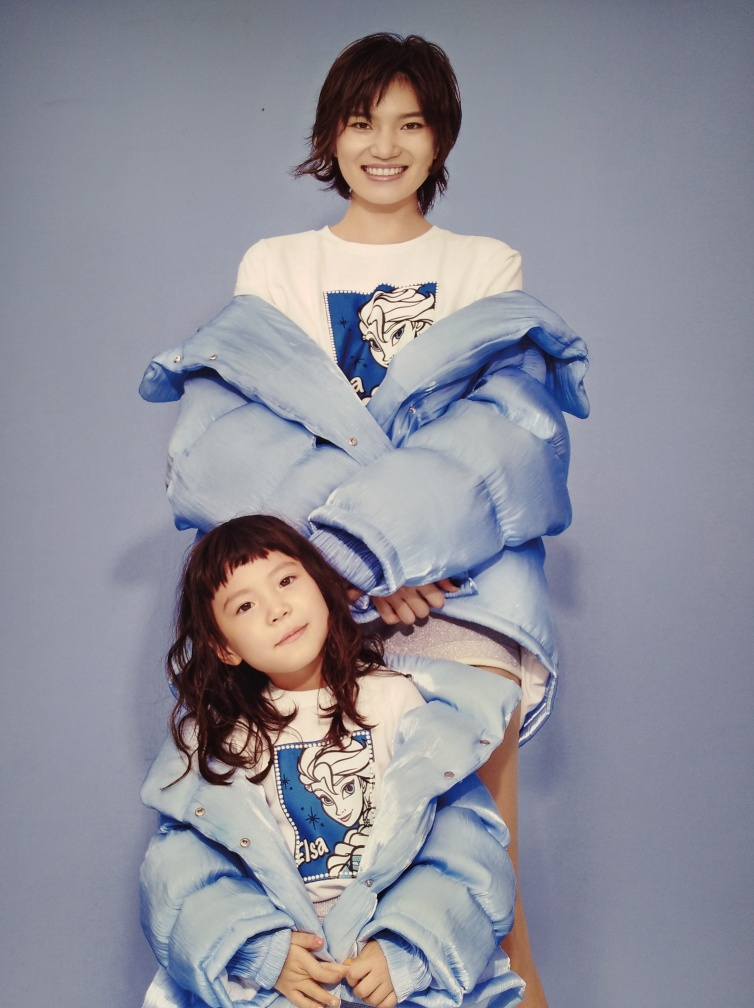What is the relationship between the two people in the picture? While I cannot specify their personal relationship, there's a sense of warmth and closeness shared between the two. They might be family members, friends, or part of a creative project that depicts them in an endearing way. 